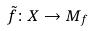Convert formula to latex. <formula><loc_0><loc_0><loc_500><loc_500>\tilde { f } \colon X \rightarrow M _ { f }</formula> 